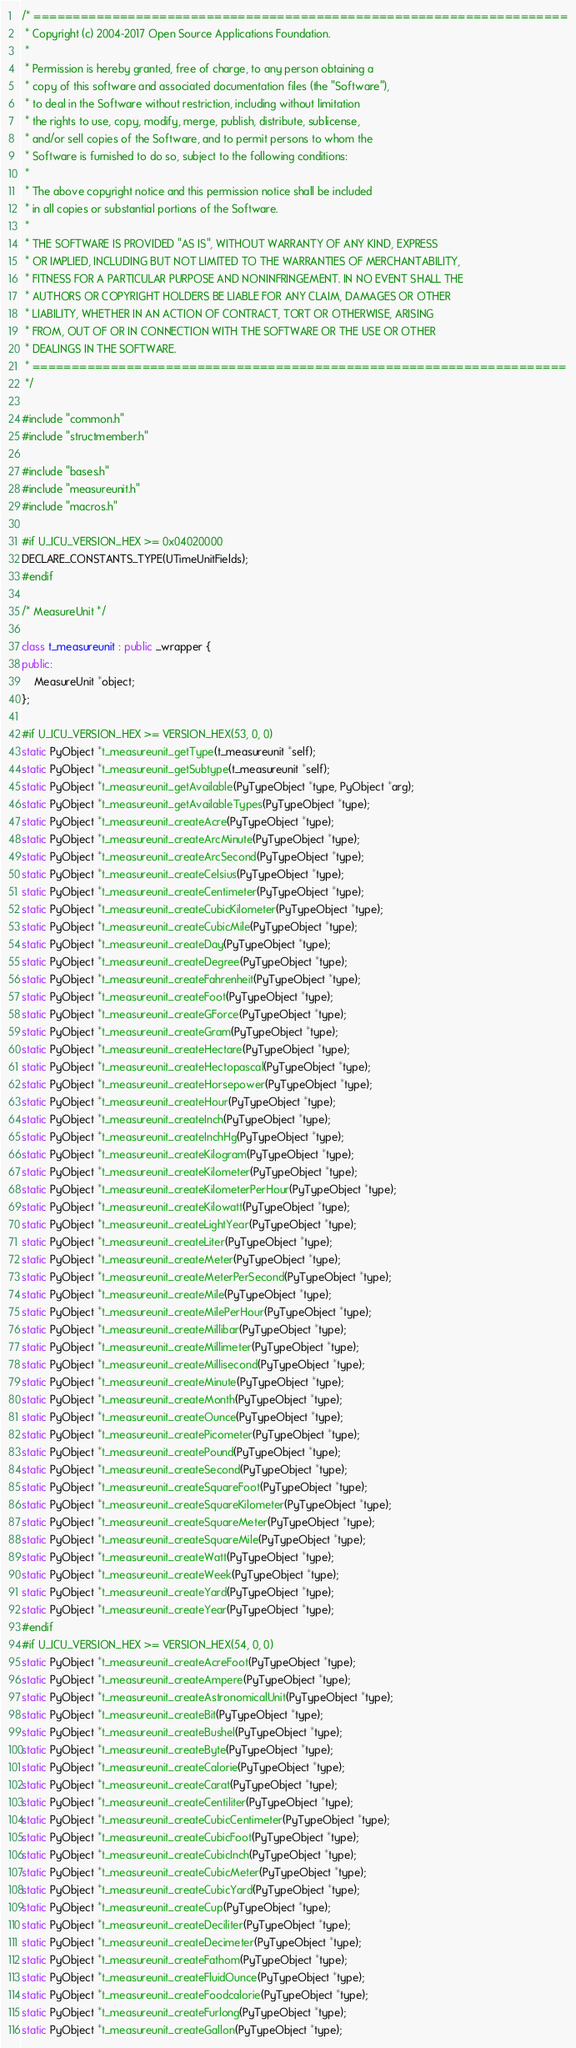<code> <loc_0><loc_0><loc_500><loc_500><_C++_>/* ====================================================================
 * Copyright (c) 2004-2017 Open Source Applications Foundation.
 *
 * Permission is hereby granted, free of charge, to any person obtaining a
 * copy of this software and associated documentation files (the "Software"),
 * to deal in the Software without restriction, including without limitation
 * the rights to use, copy, modify, merge, publish, distribute, sublicense,
 * and/or sell copies of the Software, and to permit persons to whom the
 * Software is furnished to do so, subject to the following conditions:
 *
 * The above copyright notice and this permission notice shall be included
 * in all copies or substantial portions of the Software.
 *
 * THE SOFTWARE IS PROVIDED "AS IS", WITHOUT WARRANTY OF ANY KIND, EXPRESS
 * OR IMPLIED, INCLUDING BUT NOT LIMITED TO THE WARRANTIES OF MERCHANTABILITY,
 * FITNESS FOR A PARTICULAR PURPOSE AND NONINFRINGEMENT. IN NO EVENT SHALL THE
 * AUTHORS OR COPYRIGHT HOLDERS BE LIABLE FOR ANY CLAIM, DAMAGES OR OTHER
 * LIABILITY, WHETHER IN AN ACTION OF CONTRACT, TORT OR OTHERWISE, ARISING
 * FROM, OUT OF OR IN CONNECTION WITH THE SOFTWARE OR THE USE OR OTHER
 * DEALINGS IN THE SOFTWARE.
 * ====================================================================
 */

#include "common.h"
#include "structmember.h"

#include "bases.h"
#include "measureunit.h"
#include "macros.h"

#if U_ICU_VERSION_HEX >= 0x04020000
DECLARE_CONSTANTS_TYPE(UTimeUnitFields);
#endif

/* MeasureUnit */

class t_measureunit : public _wrapper {
public:
    MeasureUnit *object;
};

#if U_ICU_VERSION_HEX >= VERSION_HEX(53, 0, 0)
static PyObject *t_measureunit_getType(t_measureunit *self);
static PyObject *t_measureunit_getSubtype(t_measureunit *self);
static PyObject *t_measureunit_getAvailable(PyTypeObject *type, PyObject *arg);
static PyObject *t_measureunit_getAvailableTypes(PyTypeObject *type);
static PyObject *t_measureunit_createAcre(PyTypeObject *type);
static PyObject *t_measureunit_createArcMinute(PyTypeObject *type);
static PyObject *t_measureunit_createArcSecond(PyTypeObject *type);
static PyObject *t_measureunit_createCelsius(PyTypeObject *type);
static PyObject *t_measureunit_createCentimeter(PyTypeObject *type);
static PyObject *t_measureunit_createCubicKilometer(PyTypeObject *type);
static PyObject *t_measureunit_createCubicMile(PyTypeObject *type);
static PyObject *t_measureunit_createDay(PyTypeObject *type);
static PyObject *t_measureunit_createDegree(PyTypeObject *type);
static PyObject *t_measureunit_createFahrenheit(PyTypeObject *type);
static PyObject *t_measureunit_createFoot(PyTypeObject *type);
static PyObject *t_measureunit_createGForce(PyTypeObject *type);
static PyObject *t_measureunit_createGram(PyTypeObject *type);
static PyObject *t_measureunit_createHectare(PyTypeObject *type);
static PyObject *t_measureunit_createHectopascal(PyTypeObject *type);
static PyObject *t_measureunit_createHorsepower(PyTypeObject *type);
static PyObject *t_measureunit_createHour(PyTypeObject *type);
static PyObject *t_measureunit_createInch(PyTypeObject *type);
static PyObject *t_measureunit_createInchHg(PyTypeObject *type);
static PyObject *t_measureunit_createKilogram(PyTypeObject *type);
static PyObject *t_measureunit_createKilometer(PyTypeObject *type);
static PyObject *t_measureunit_createKilometerPerHour(PyTypeObject *type);
static PyObject *t_measureunit_createKilowatt(PyTypeObject *type);
static PyObject *t_measureunit_createLightYear(PyTypeObject *type);
static PyObject *t_measureunit_createLiter(PyTypeObject *type);
static PyObject *t_measureunit_createMeter(PyTypeObject *type);
static PyObject *t_measureunit_createMeterPerSecond(PyTypeObject *type);
static PyObject *t_measureunit_createMile(PyTypeObject *type);
static PyObject *t_measureunit_createMilePerHour(PyTypeObject *type);
static PyObject *t_measureunit_createMillibar(PyTypeObject *type);
static PyObject *t_measureunit_createMillimeter(PyTypeObject *type);
static PyObject *t_measureunit_createMillisecond(PyTypeObject *type);
static PyObject *t_measureunit_createMinute(PyTypeObject *type);
static PyObject *t_measureunit_createMonth(PyTypeObject *type);
static PyObject *t_measureunit_createOunce(PyTypeObject *type);
static PyObject *t_measureunit_createPicometer(PyTypeObject *type);
static PyObject *t_measureunit_createPound(PyTypeObject *type);
static PyObject *t_measureunit_createSecond(PyTypeObject *type);
static PyObject *t_measureunit_createSquareFoot(PyTypeObject *type);
static PyObject *t_measureunit_createSquareKilometer(PyTypeObject *type);
static PyObject *t_measureunit_createSquareMeter(PyTypeObject *type);
static PyObject *t_measureunit_createSquareMile(PyTypeObject *type);
static PyObject *t_measureunit_createWatt(PyTypeObject *type);
static PyObject *t_measureunit_createWeek(PyTypeObject *type);
static PyObject *t_measureunit_createYard(PyTypeObject *type);
static PyObject *t_measureunit_createYear(PyTypeObject *type);
#endif
#if U_ICU_VERSION_HEX >= VERSION_HEX(54, 0, 0)
static PyObject *t_measureunit_createAcreFoot(PyTypeObject *type);
static PyObject *t_measureunit_createAmpere(PyTypeObject *type);
static PyObject *t_measureunit_createAstronomicalUnit(PyTypeObject *type);
static PyObject *t_measureunit_createBit(PyTypeObject *type);
static PyObject *t_measureunit_createBushel(PyTypeObject *type);
static PyObject *t_measureunit_createByte(PyTypeObject *type);
static PyObject *t_measureunit_createCalorie(PyTypeObject *type);
static PyObject *t_measureunit_createCarat(PyTypeObject *type);
static PyObject *t_measureunit_createCentiliter(PyTypeObject *type);
static PyObject *t_measureunit_createCubicCentimeter(PyTypeObject *type);
static PyObject *t_measureunit_createCubicFoot(PyTypeObject *type);
static PyObject *t_measureunit_createCubicInch(PyTypeObject *type);
static PyObject *t_measureunit_createCubicMeter(PyTypeObject *type);
static PyObject *t_measureunit_createCubicYard(PyTypeObject *type);
static PyObject *t_measureunit_createCup(PyTypeObject *type);
static PyObject *t_measureunit_createDeciliter(PyTypeObject *type);
static PyObject *t_measureunit_createDecimeter(PyTypeObject *type);
static PyObject *t_measureunit_createFathom(PyTypeObject *type);
static PyObject *t_measureunit_createFluidOunce(PyTypeObject *type);
static PyObject *t_measureunit_createFoodcalorie(PyTypeObject *type);
static PyObject *t_measureunit_createFurlong(PyTypeObject *type);
static PyObject *t_measureunit_createGallon(PyTypeObject *type);</code> 